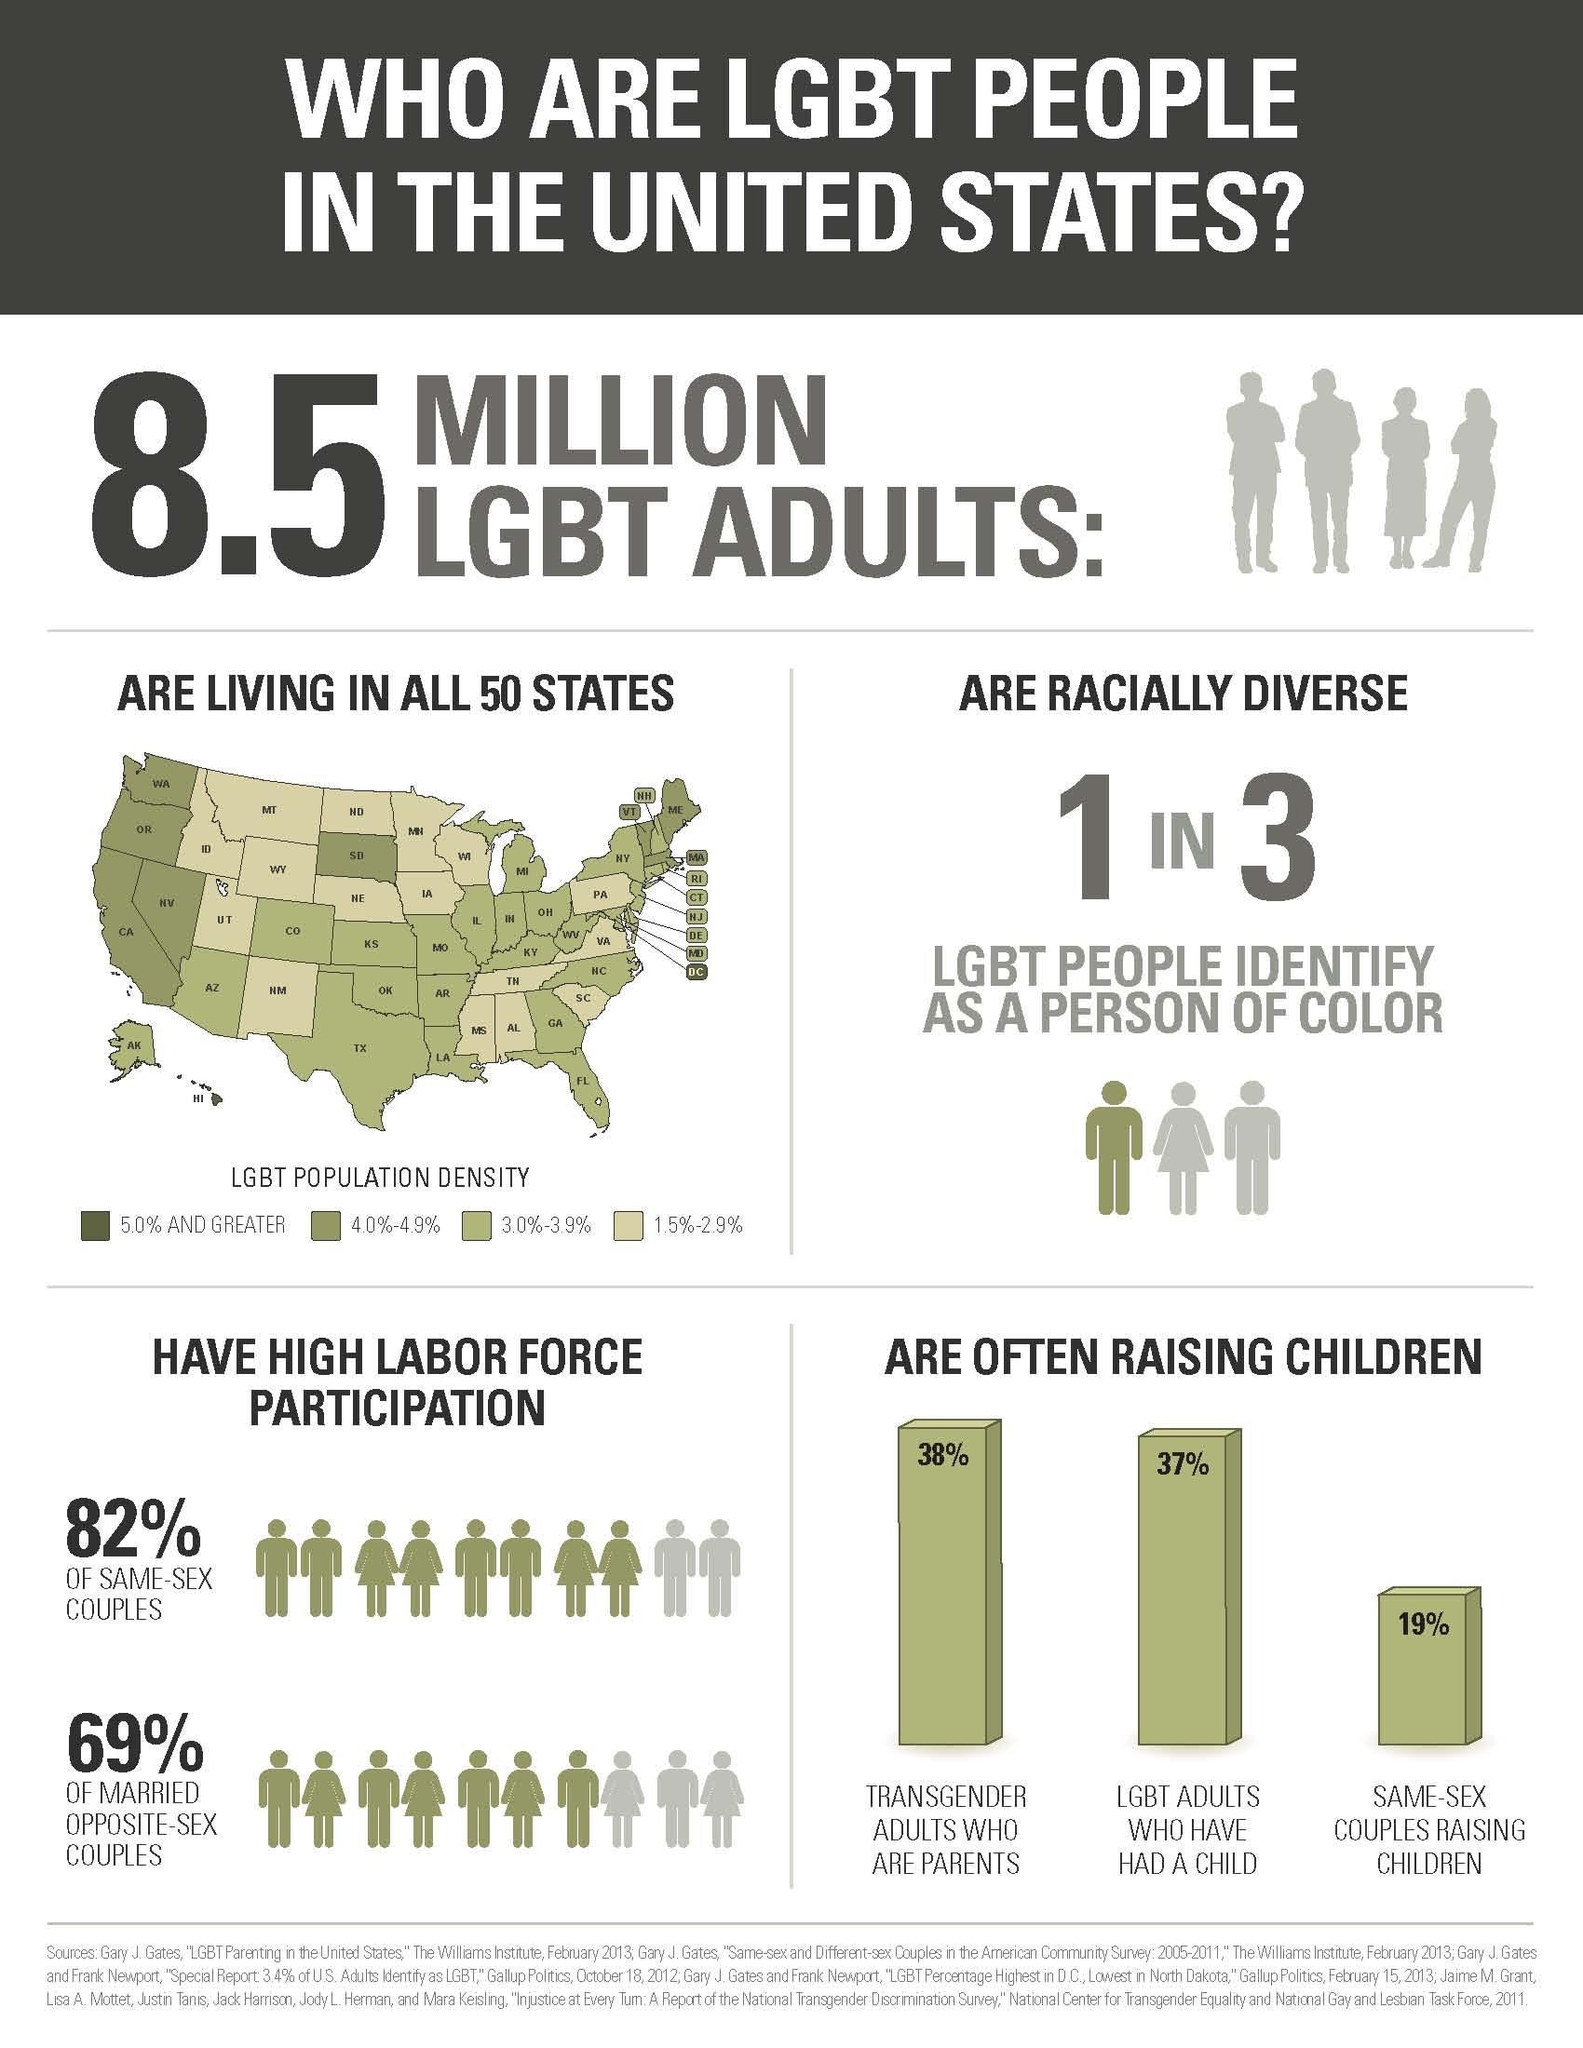What is the total LGBT population in the United States?
Answer the question with a short phrase. 8.5 MILLION What percentage of same-sex couples are raising children in the U.S? 19% What percentage of LGBT adults have had a child in the U.S.? 37% What percentage of transgender adults are parents in the U.S.? 38% What is the LGBT population density in Montana(MT) state of U.S.? 1.5%-2.9% What is the LGBT population density in Washington(WA) state of U.S.? 4.0%-4.9% What is the LGBT population density in New Mexico(NM) state of U.S.? 1.5%-2.9% What is the LGBT population density in Hawaii state of U.S.? 5.0% AND GREATER 